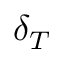Convert formula to latex. <formula><loc_0><loc_0><loc_500><loc_500>\delta _ { T }</formula> 